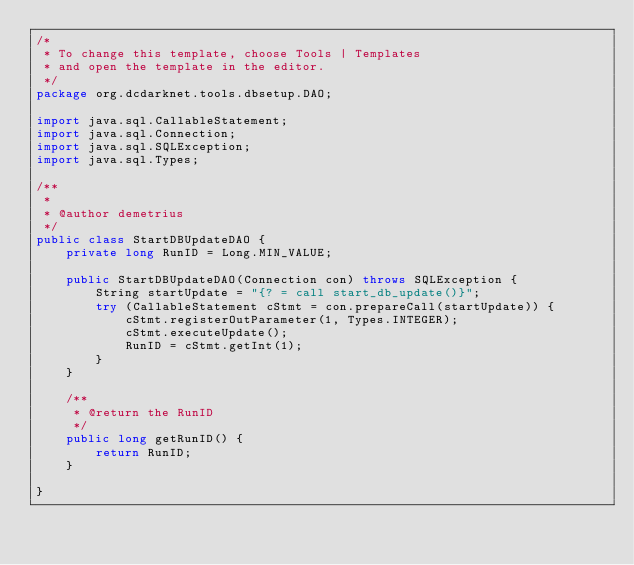Convert code to text. <code><loc_0><loc_0><loc_500><loc_500><_Java_>/*
 * To change this template, choose Tools | Templates
 * and open the template in the editor.
 */
package org.dcdarknet.tools.dbsetup.DAO;

import java.sql.CallableStatement;
import java.sql.Connection;
import java.sql.SQLException;
import java.sql.Types;

/**
 *
 * @author demetrius
 */
public class StartDBUpdateDAO {
    private long RunID = Long.MIN_VALUE;

    public StartDBUpdateDAO(Connection con) throws SQLException {
        String startUpdate = "{? = call start_db_update()}";
        try (CallableStatement cStmt = con.prepareCall(startUpdate)) {
            cStmt.registerOutParameter(1, Types.INTEGER);
            cStmt.executeUpdate();
            RunID = cStmt.getInt(1);
        }
    }

    /**
     * @return the RunID
     */
    public long getRunID() {
        return RunID;
    }

}
</code> 